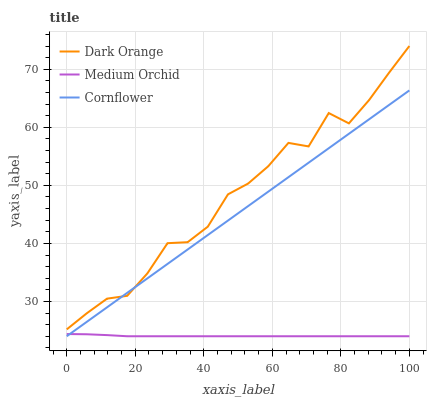Does Medium Orchid have the minimum area under the curve?
Answer yes or no. Yes. Does Dark Orange have the maximum area under the curve?
Answer yes or no. Yes. Does Cornflower have the minimum area under the curve?
Answer yes or no. No. Does Cornflower have the maximum area under the curve?
Answer yes or no. No. Is Cornflower the smoothest?
Answer yes or no. Yes. Is Dark Orange the roughest?
Answer yes or no. Yes. Is Medium Orchid the smoothest?
Answer yes or no. No. Is Medium Orchid the roughest?
Answer yes or no. No. Does Medium Orchid have the lowest value?
Answer yes or no. Yes. Does Dark Orange have the highest value?
Answer yes or no. Yes. Does Cornflower have the highest value?
Answer yes or no. No. Is Medium Orchid less than Dark Orange?
Answer yes or no. Yes. Is Dark Orange greater than Medium Orchid?
Answer yes or no. Yes. Does Medium Orchid intersect Cornflower?
Answer yes or no. Yes. Is Medium Orchid less than Cornflower?
Answer yes or no. No. Is Medium Orchid greater than Cornflower?
Answer yes or no. No. Does Medium Orchid intersect Dark Orange?
Answer yes or no. No. 